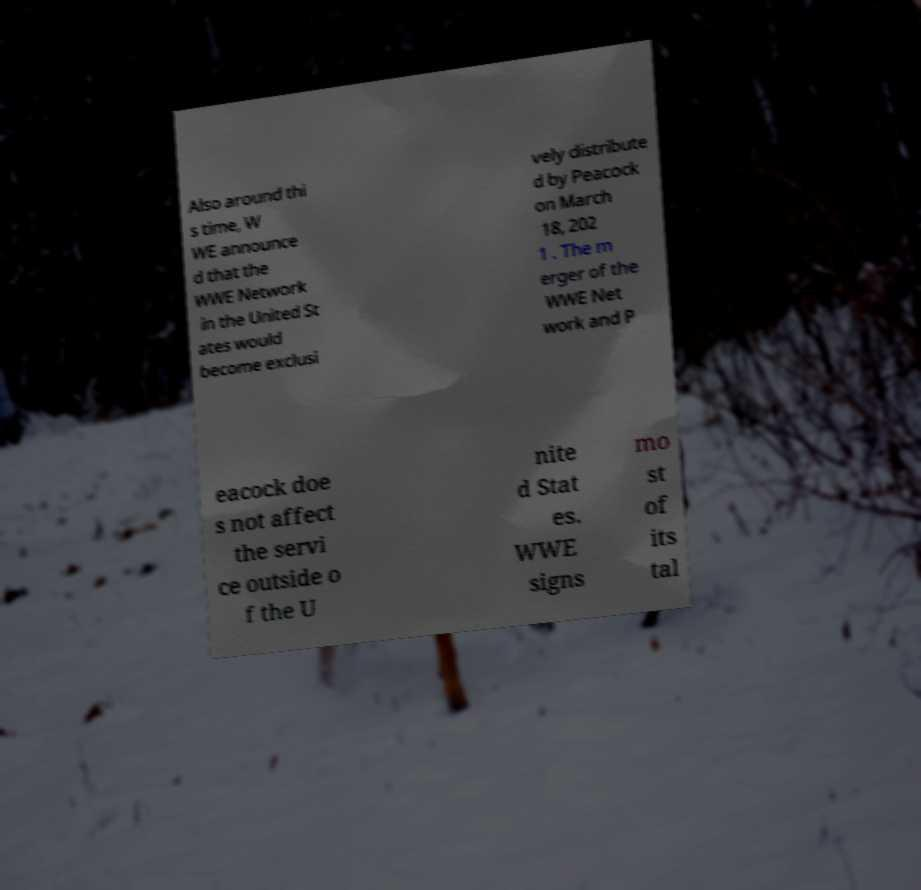What messages or text are displayed in this image? I need them in a readable, typed format. Also around thi s time, W WE announce d that the WWE Network in the United St ates would become exclusi vely distribute d by Peacock on March 18, 202 1 . The m erger of the WWE Net work and P eacock doe s not affect the servi ce outside o f the U nite d Stat es. WWE signs mo st of its tal 